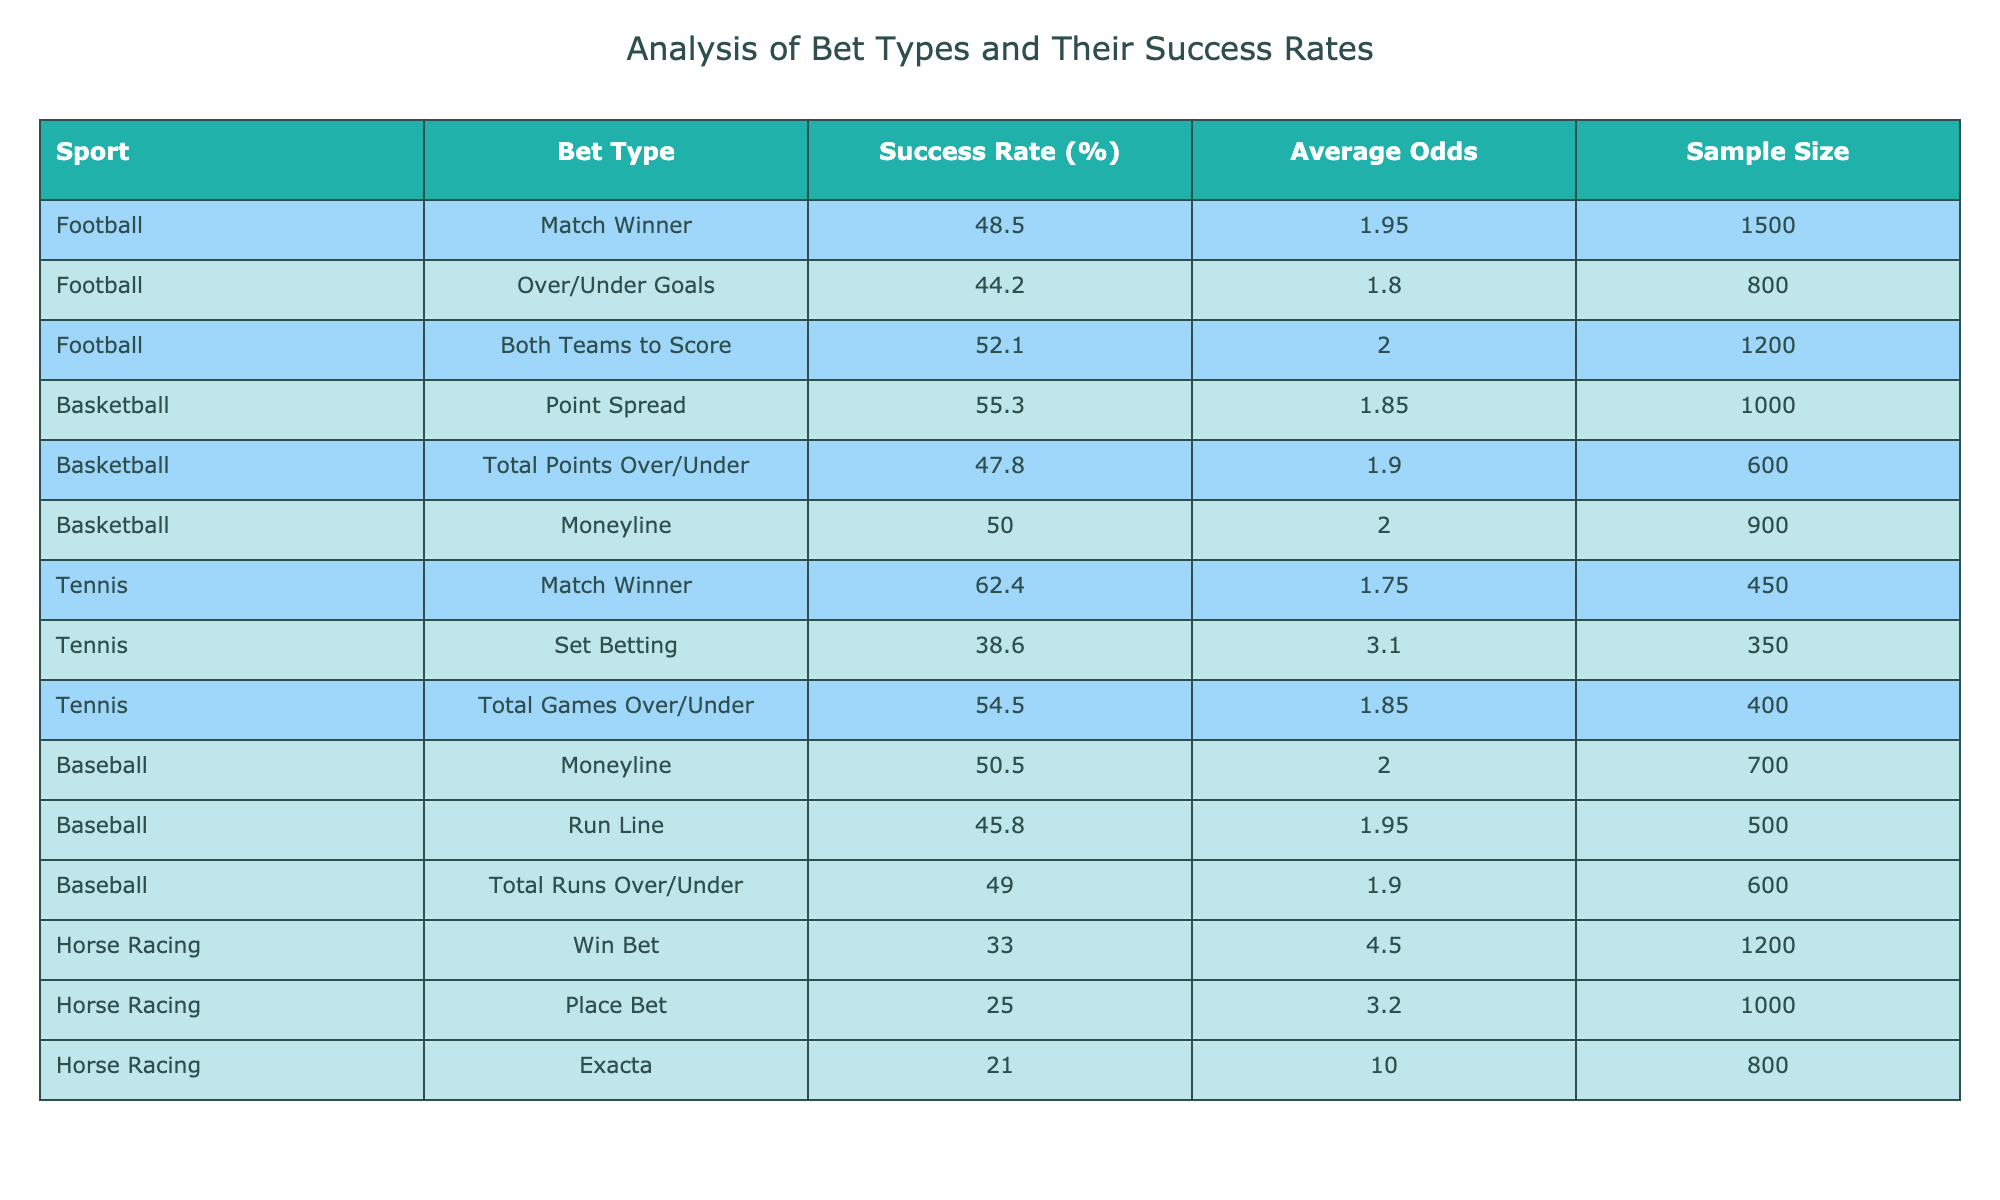What is the success rate for the "Both Teams to Score" bet type in Football? The table shows that the success rate for the "Both Teams to Score" bet type under Football is 52.1%.
Answer: 52.1% Which sport has the highest success rate for its bet types? Looking through the success rates, Tennis stands out with the highest success rate for its "Match Winner" bet type at 62.4%.
Answer: Tennis What is the average success rate for all bet types in Baseball? The success rates for Baseball are 50.5% (Moneyline), 45.8% (Run Line), and 49.0% (Total Runs Over/Under). The average is calculated as (50.5 + 45.8 + 49.0) / 3 = 48.43%.
Answer: 48.43% Is the success rate for Tennis's "Set Betting" higher than 40%? The "Set Betting" success rate for Tennis is 38.6%, which is below 40%. Therefore, it is false that it is higher than 40%.
Answer: No Which bet type has the lowest success rate in the table, and what is that rate? The "Exacta" bet type in Horse Racing has the lowest success rate listed at 21.0%.
Answer: 21.0% 